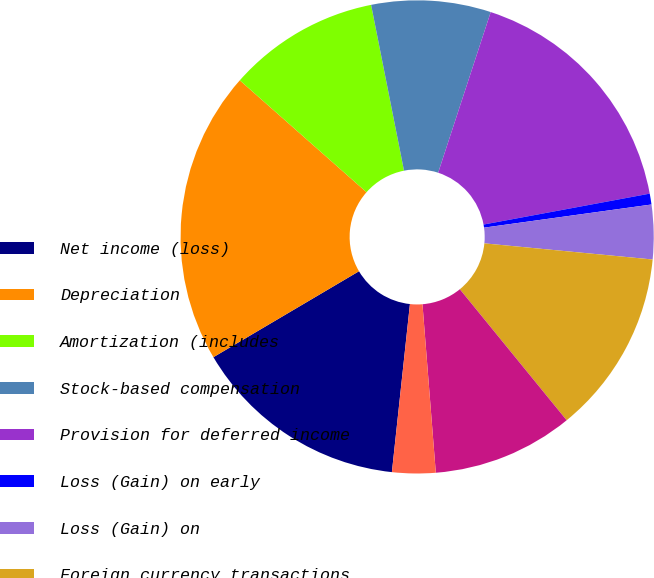Convert chart to OTSL. <chart><loc_0><loc_0><loc_500><loc_500><pie_chart><fcel>Net income (loss)<fcel>Depreciation<fcel>Amortization (includes<fcel>Stock-based compensation<fcel>Provision for deferred income<fcel>Loss (Gain) on early<fcel>Loss (Gain) on<fcel>Foreign currency transactions<fcel>Accounts receivable<fcel>Prepaid expenses and other<nl><fcel>14.81%<fcel>20.0%<fcel>10.37%<fcel>8.15%<fcel>17.04%<fcel>0.74%<fcel>3.71%<fcel>12.59%<fcel>9.63%<fcel>2.96%<nl></chart> 